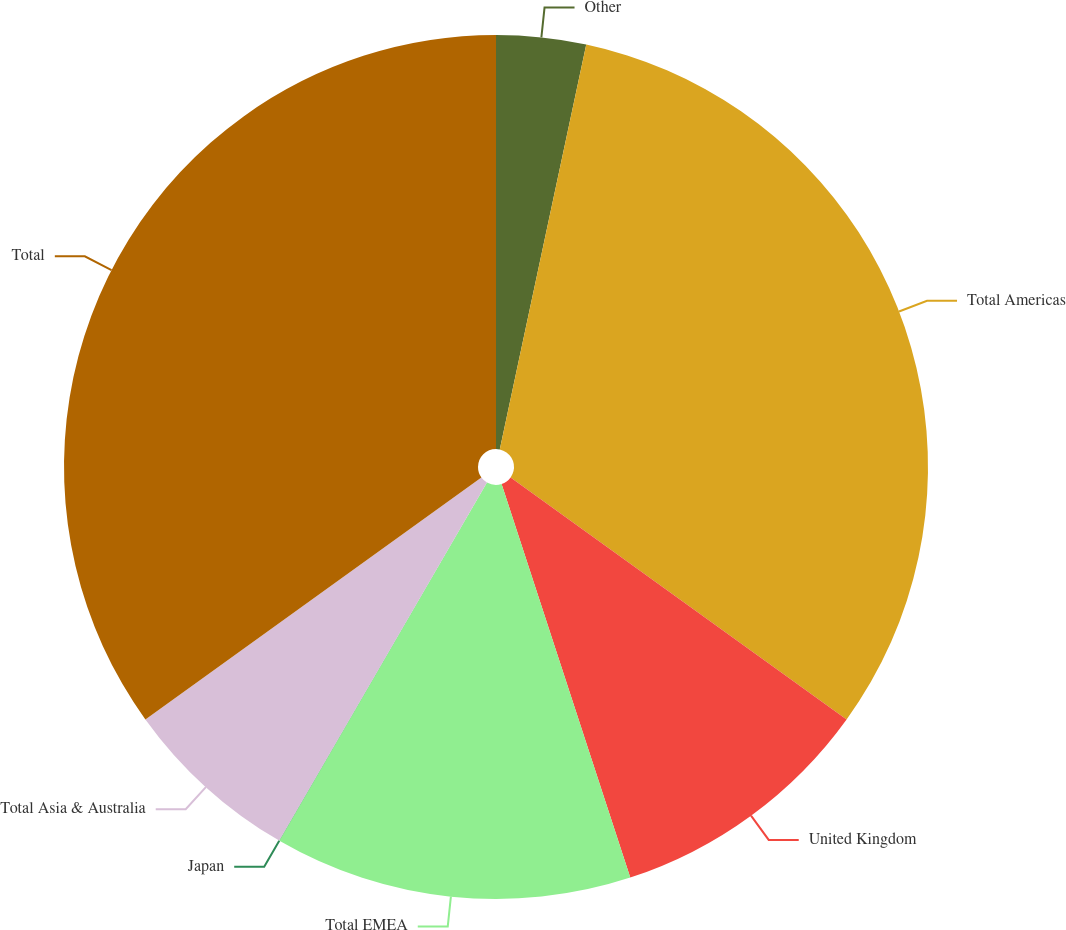Convert chart. <chart><loc_0><loc_0><loc_500><loc_500><pie_chart><fcel>Other<fcel>Total Americas<fcel>United Kingdom<fcel>Total EMEA<fcel>Japan<fcel>Total Asia & Australia<fcel>Total<nl><fcel>3.35%<fcel>31.58%<fcel>10.04%<fcel>13.39%<fcel>0.01%<fcel>6.7%<fcel>34.93%<nl></chart> 